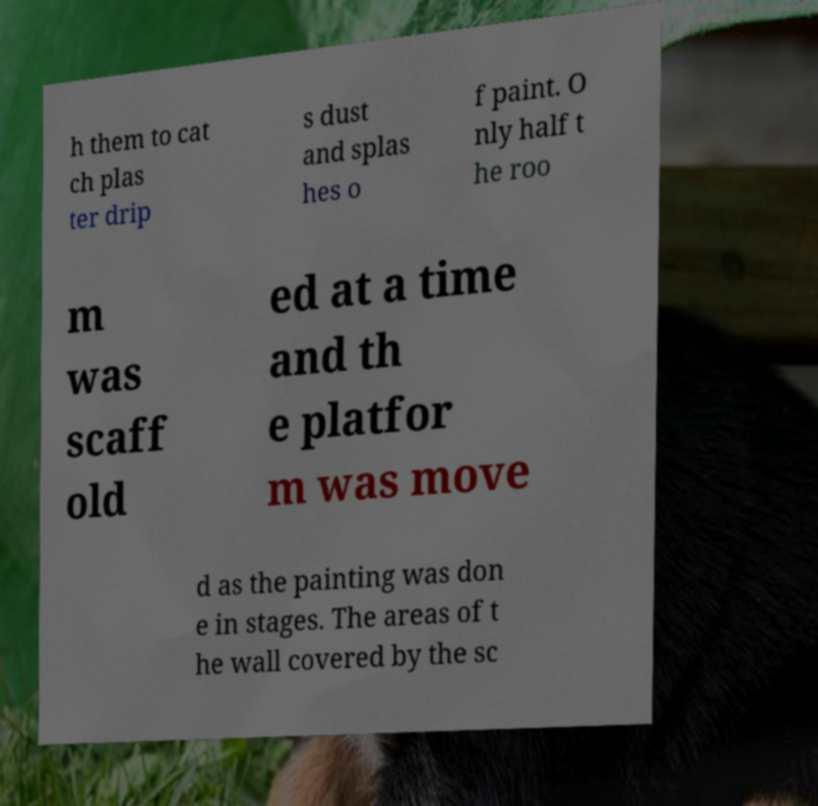Can you read and provide the text displayed in the image?This photo seems to have some interesting text. Can you extract and type it out for me? h them to cat ch plas ter drip s dust and splas hes o f paint. O nly half t he roo m was scaff old ed at a time and th e platfor m was move d as the painting was don e in stages. The areas of t he wall covered by the sc 